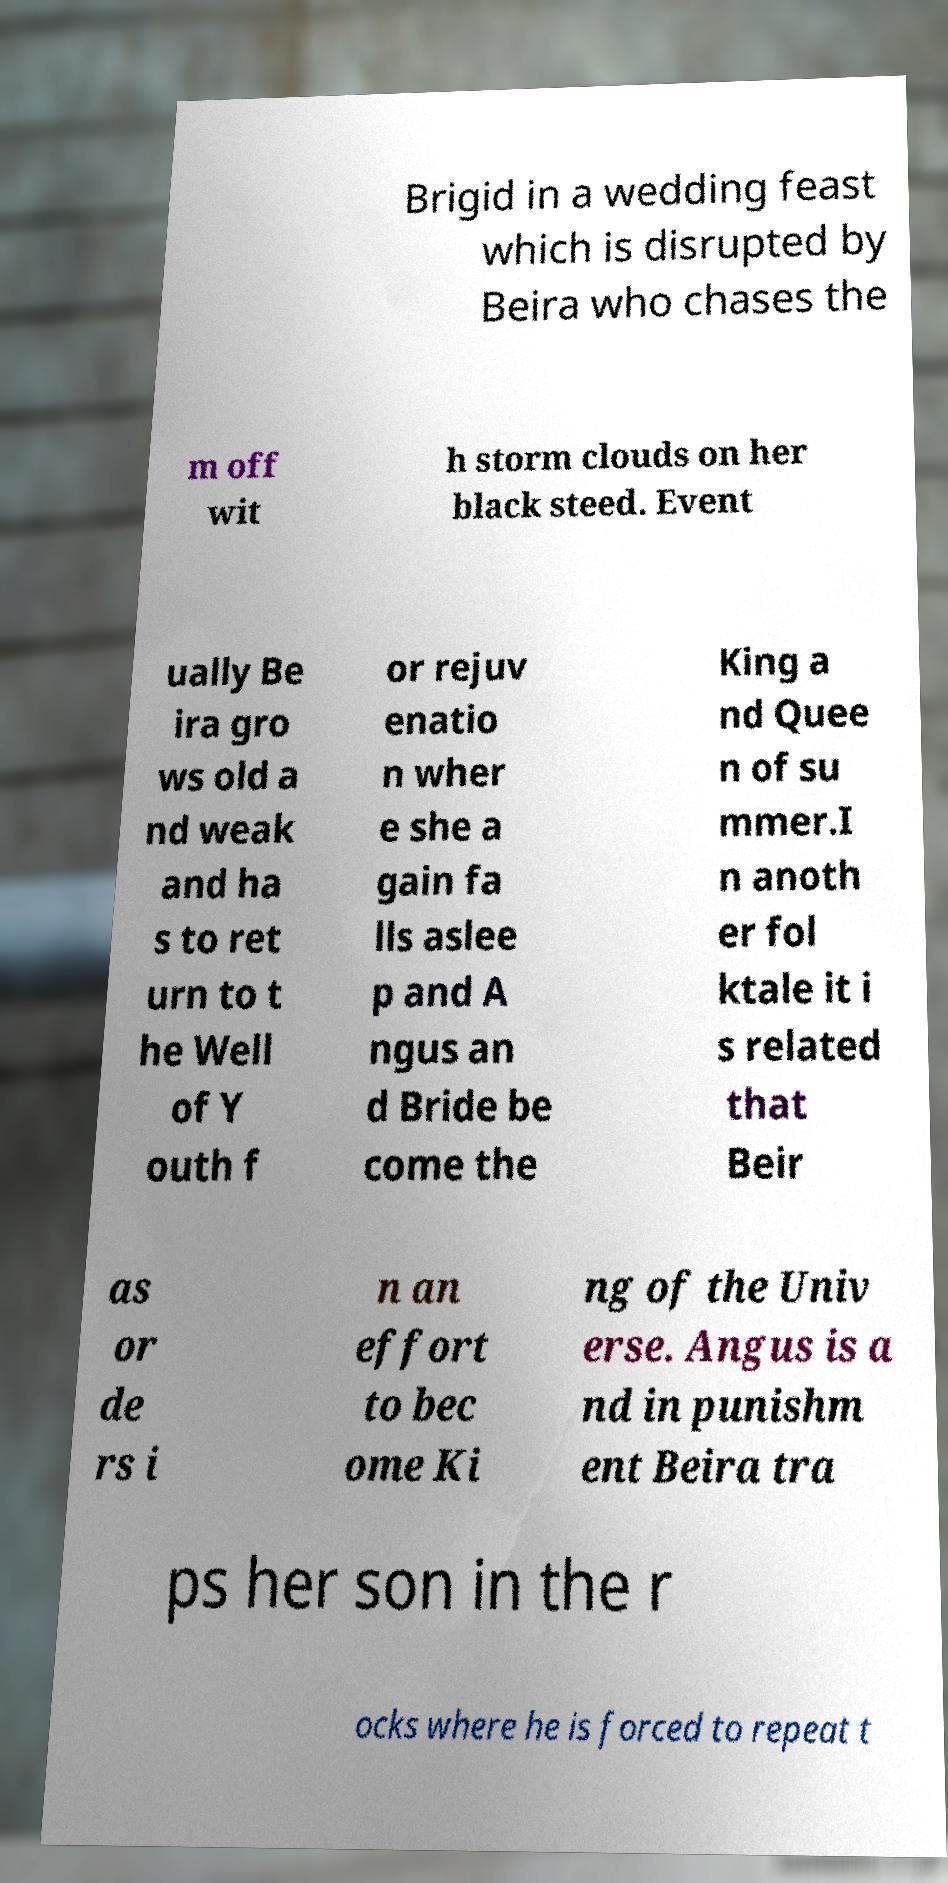For documentation purposes, I need the text within this image transcribed. Could you provide that? Brigid in a wedding feast which is disrupted by Beira who chases the m off wit h storm clouds on her black steed. Event ually Be ira gro ws old a nd weak and ha s to ret urn to t he Well of Y outh f or rejuv enatio n wher e she a gain fa lls aslee p and A ngus an d Bride be come the King a nd Quee n of su mmer.I n anoth er fol ktale it i s related that Beir as or de rs i n an effort to bec ome Ki ng of the Univ erse. Angus is a nd in punishm ent Beira tra ps her son in the r ocks where he is forced to repeat t 